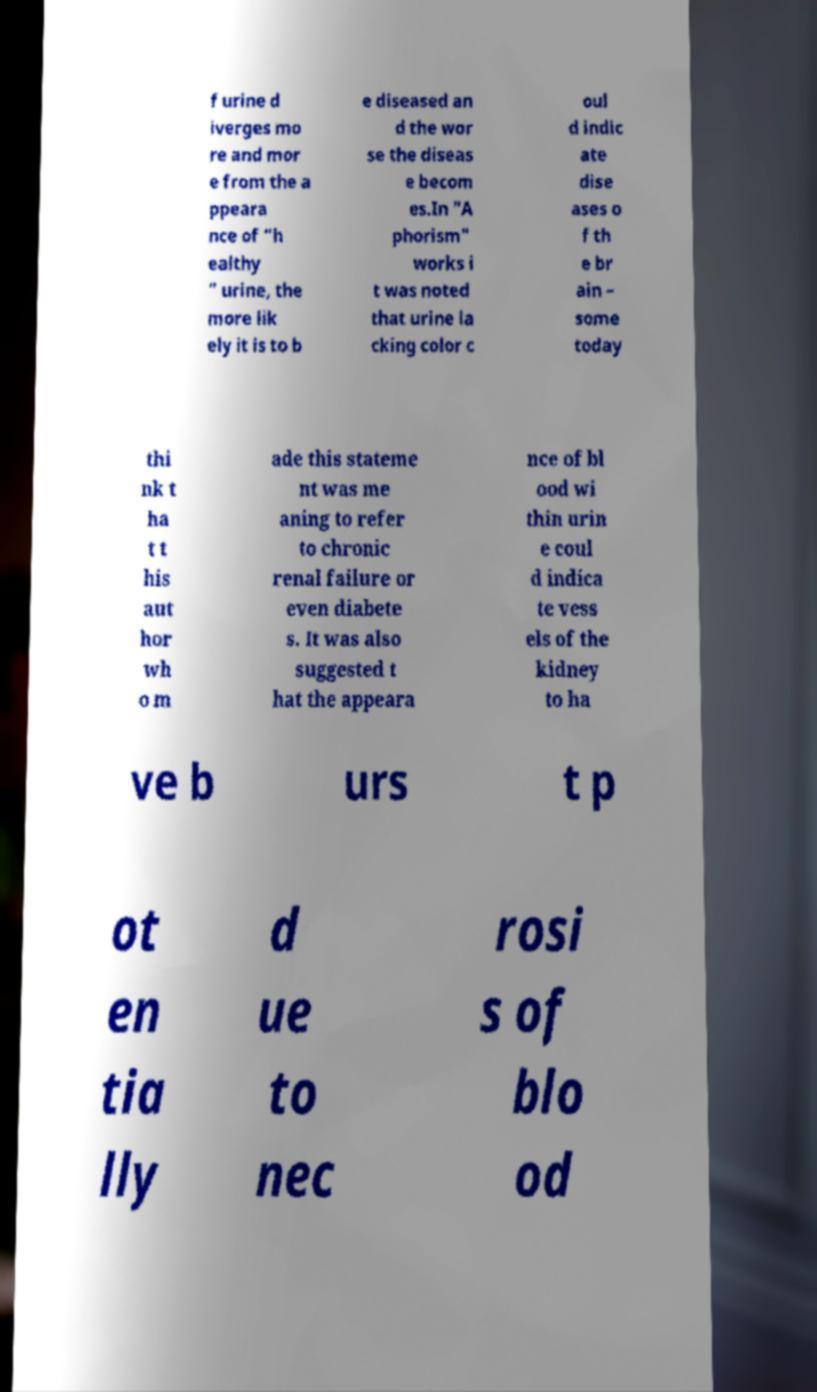Please identify and transcribe the text found in this image. f urine d iverges mo re and mor e from the a ppeara nce of “h ealthy ” urine, the more lik ely it is to b e diseased an d the wor se the diseas e becom es.In "A phorism" works i t was noted that urine la cking color c oul d indic ate dise ases o f th e br ain – some today thi nk t ha t t his aut hor wh o m ade this stateme nt was me aning to refer to chronic renal failure or even diabete s. It was also suggested t hat the appeara nce of bl ood wi thin urin e coul d indica te vess els of the kidney to ha ve b urs t p ot en tia lly d ue to nec rosi s of blo od 